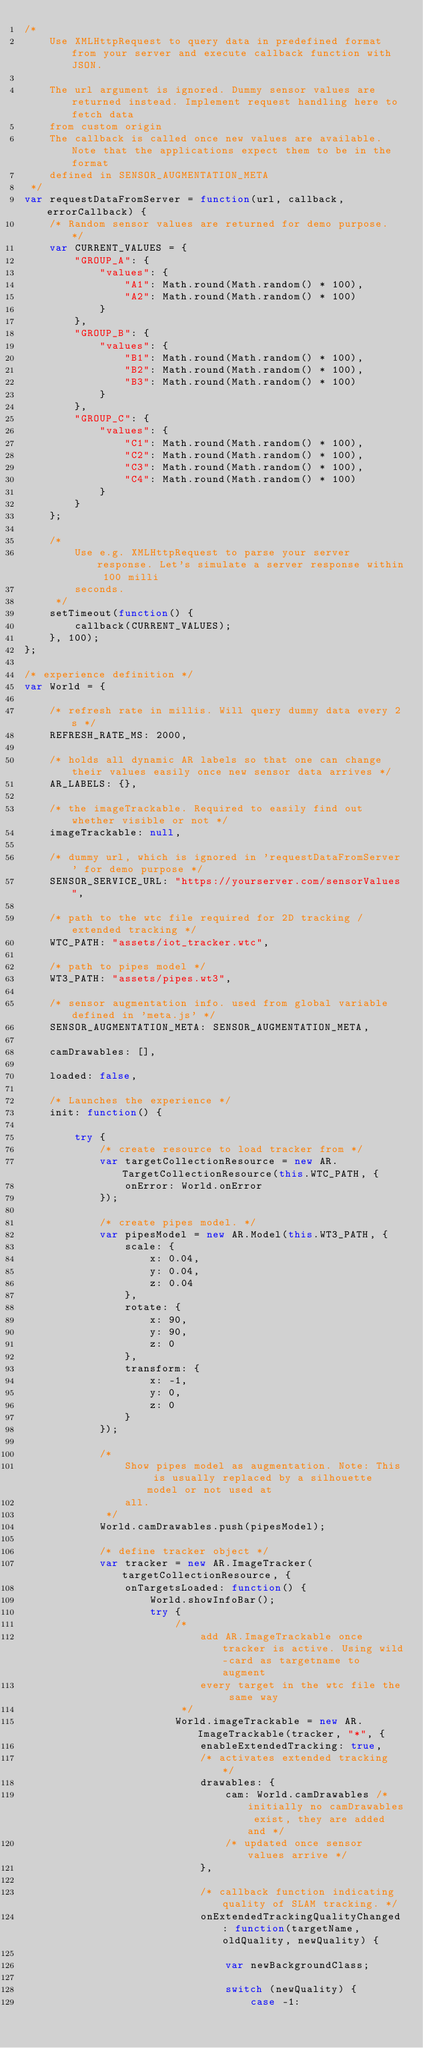Convert code to text. <code><loc_0><loc_0><loc_500><loc_500><_JavaScript_>/*
    Use XMLHttpRequest to query data in predefined format from your server and execute callback function with JSON.

    The url argument is ignored. Dummy sensor values are returned instead. Implement request handling here to fetch data
    from custom origin
    The callback is called once new values are available. Note that the applications expect them to be in the format
    defined in SENSOR_AUGMENTATION_META
 */
var requestDataFromServer = function(url, callback, errorCallback) {
    /* Random sensor values are returned for demo purpose. */
    var CURRENT_VALUES = {
        "GROUP_A": {
            "values": {
                "A1": Math.round(Math.random() * 100),
                "A2": Math.round(Math.random() * 100)
            }
        },
        "GROUP_B": {
            "values": {
                "B1": Math.round(Math.random() * 100),
                "B2": Math.round(Math.random() * 100),
                "B3": Math.round(Math.random() * 100)
            }
        },
        "GROUP_C": {
            "values": {
                "C1": Math.round(Math.random() * 100),
                "C2": Math.round(Math.random() * 100),
                "C3": Math.round(Math.random() * 100),
                "C4": Math.round(Math.random() * 100)
            }
        }
    };

    /*
        Use e.g. XMLHttpRequest to parse your server response. Let's simulate a server response within 100 milli
        seconds.
     */
    setTimeout(function() {
        callback(CURRENT_VALUES);
    }, 100);
};

/* experience definition */
var World = {

    /* refresh rate in millis. Will query dummy data every 2s */
    REFRESH_RATE_MS: 2000,

    /* holds all dynamic AR labels so that one can change their values easily once new sensor data arrives */
    AR_LABELS: {},

    /* the imageTrackable. Required to easily find out whether visible or not */
    imageTrackable: null,

    /* dummy url, which is ignored in 'requestDataFromServer' for demo purpose */
    SENSOR_SERVICE_URL: "https://yourserver.com/sensorValues",

    /* path to the wtc file required for 2D tracking / extended tracking */
    WTC_PATH: "assets/iot_tracker.wtc",

    /* path to pipes model */
    WT3_PATH: "assets/pipes.wt3",

    /* sensor augmentation info. used from global variable defined in 'meta.js' */
    SENSOR_AUGMENTATION_META: SENSOR_AUGMENTATION_META,

    camDrawables: [],

    loaded: false,

    /* Launches the experience */
    init: function() {

        try {
            /* create resource to load tracker from */
            var targetCollectionResource = new AR.TargetCollectionResource(this.WTC_PATH, {
                onError: World.onError
            });

            /* create pipes model. */
            var pipesModel = new AR.Model(this.WT3_PATH, {
                scale: {
                    x: 0.04,
                    y: 0.04,
                    z: 0.04
                },
                rotate: {
                    x: 90,
                    y: 90,
                    z: 0
                },
                transform: {
                    x: -1,
                    y: 0,
                    z: 0
                }
            });

            /*
                Show pipes model as augmentation. Note: This is usually replaced by a silhouette model or not used at
                all.
             */
            World.camDrawables.push(pipesModel);

            /* define tracker object */
            var tracker = new AR.ImageTracker(targetCollectionResource, {
                onTargetsLoaded: function() {
                    World.showInfoBar();
                    try {
                        /*
                            add AR.ImageTrackable once tracker is active. Using wild-card as targetname to augment
                            every target in the wtc file the same way
                         */
                        World.imageTrackable = new AR.ImageTrackable(tracker, "*", {
                            enableExtendedTracking: true,
                            /* activates extended tracking */
                            drawables: {
                                cam: World.camDrawables /* initially no camDrawables exist, they are added and */
                                /* updated once sensor values arrive */
                            },

                            /* callback function indicating quality of SLAM tracking. */
                            onExtendedTrackingQualityChanged: function(targetName, oldQuality, newQuality) {

                                var newBackgroundClass;

                                switch (newQuality) {
                                    case -1:</code> 